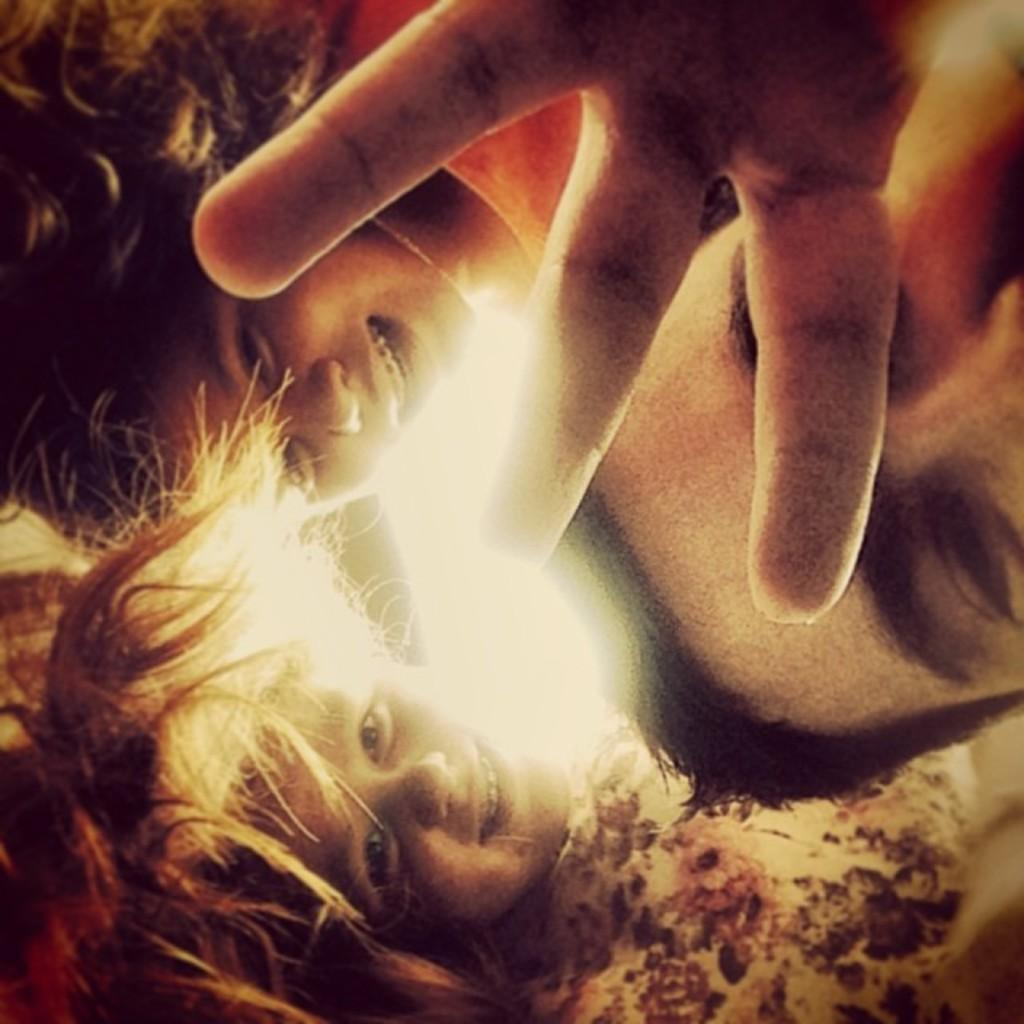How many people are in the image? There is a group of people in the image. What is the facial expression of the people in the image? The people are all smiling. What type of oven is visible in the image? There is no oven present in the image. What kind of picture is hanging on the wall in the image? There is no picture hanging on the wall in the image. 